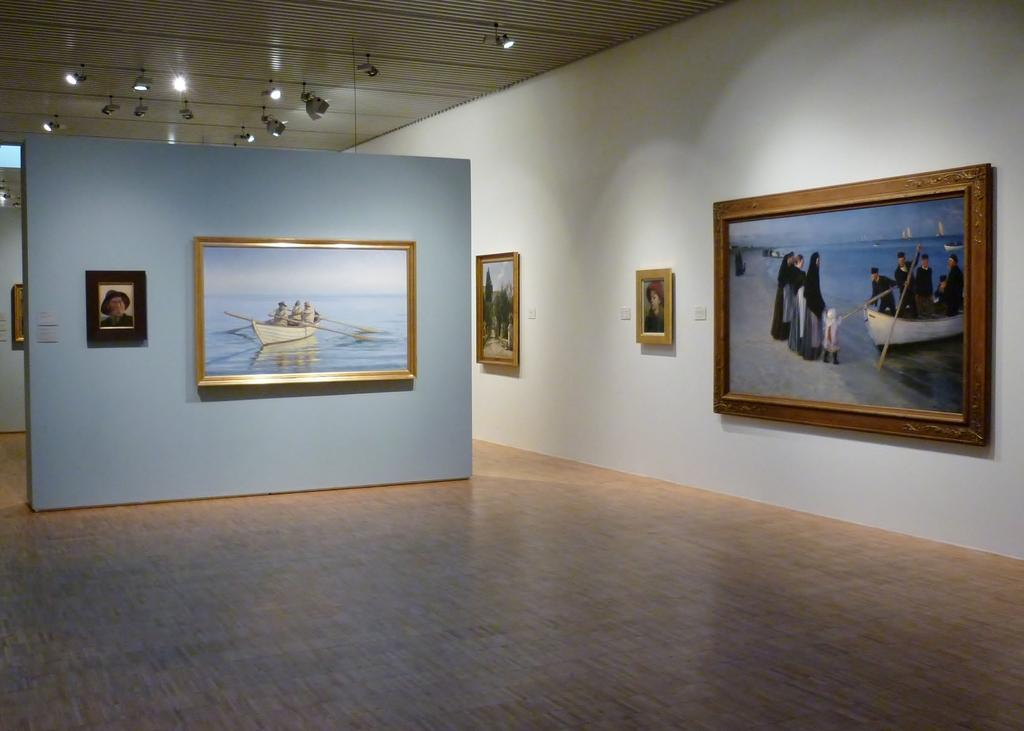What type of space is depicted in the image? There is a hall in the image. What can be seen on the walls of the hall? There are photo frames on white and blue color walls in the hall. How are the photo frames arranged in the hall? The photo frames are arranged on the floor in the hall. What is present on the ceiling of the hall? There are lights attached to the roof in the hall. What type of lunch is being served in the hall in the image? There is no lunch being served in the hall in the image; the focus is on the photo frames and lights. 